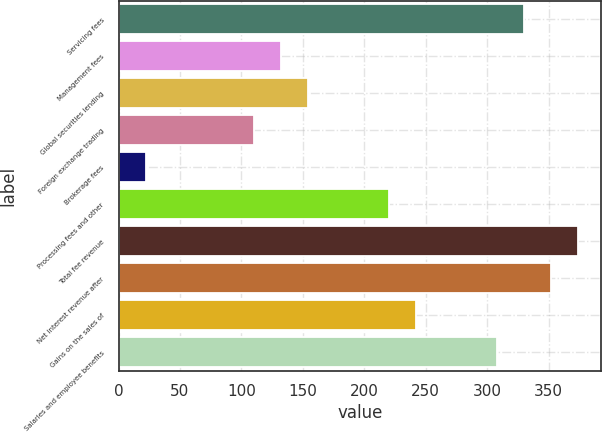Convert chart to OTSL. <chart><loc_0><loc_0><loc_500><loc_500><bar_chart><fcel>Servicing fees<fcel>Management fees<fcel>Global securities lending<fcel>Foreign exchange trading<fcel>Brokerage fees<fcel>Processing fees and other<fcel>Total fee revenue<fcel>Net interest revenue after<fcel>Gains on the sales of<fcel>Salaries and employee benefits<nl><fcel>329.86<fcel>132.04<fcel>154.02<fcel>110.06<fcel>22.14<fcel>219.96<fcel>373.82<fcel>351.84<fcel>241.94<fcel>307.88<nl></chart> 